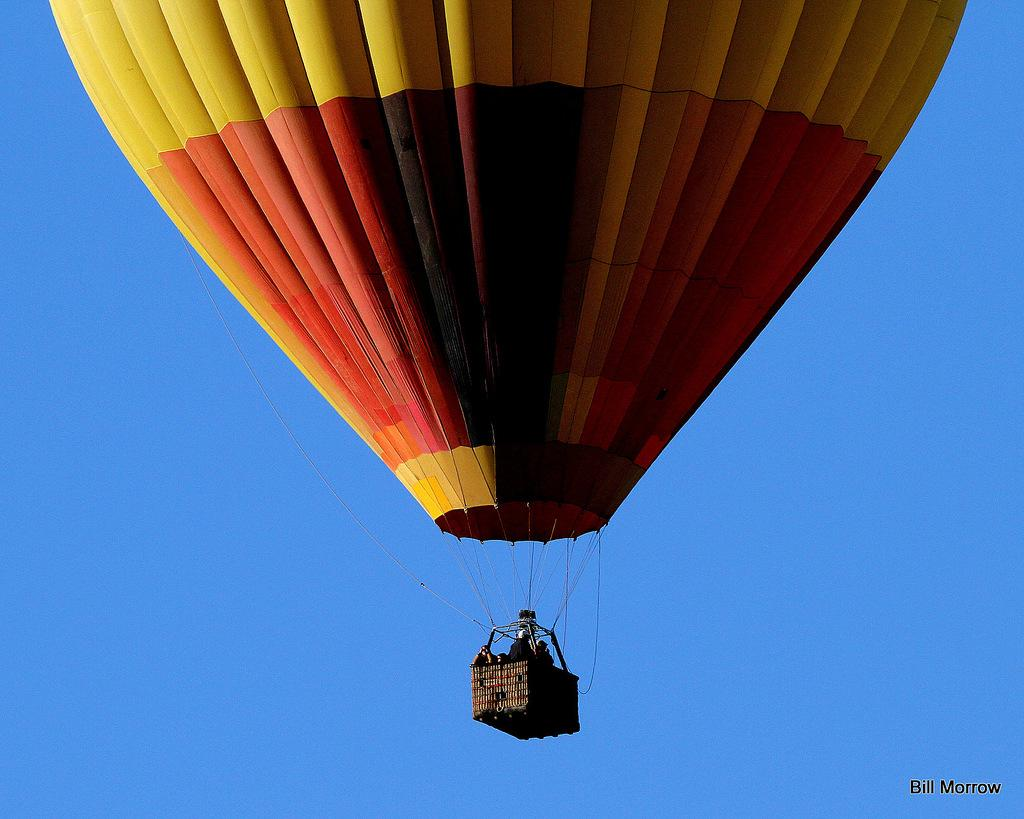What activity are the people in the image engaged in? The people in the image are paragliding. What can be seen in the background of the image? The sky is visible in the background of the image. What is the color of the sky in the image? The sky is blue in color. Where is the text located in the image? The text is in the bottom right side of the image. What type of industry can be seen in the image? There is no industry present in the image; it features people paragliding against a blue sky. Can you describe the harbor in the image? There is no harbor present in the image; it features people paragliding against a blue sky. 